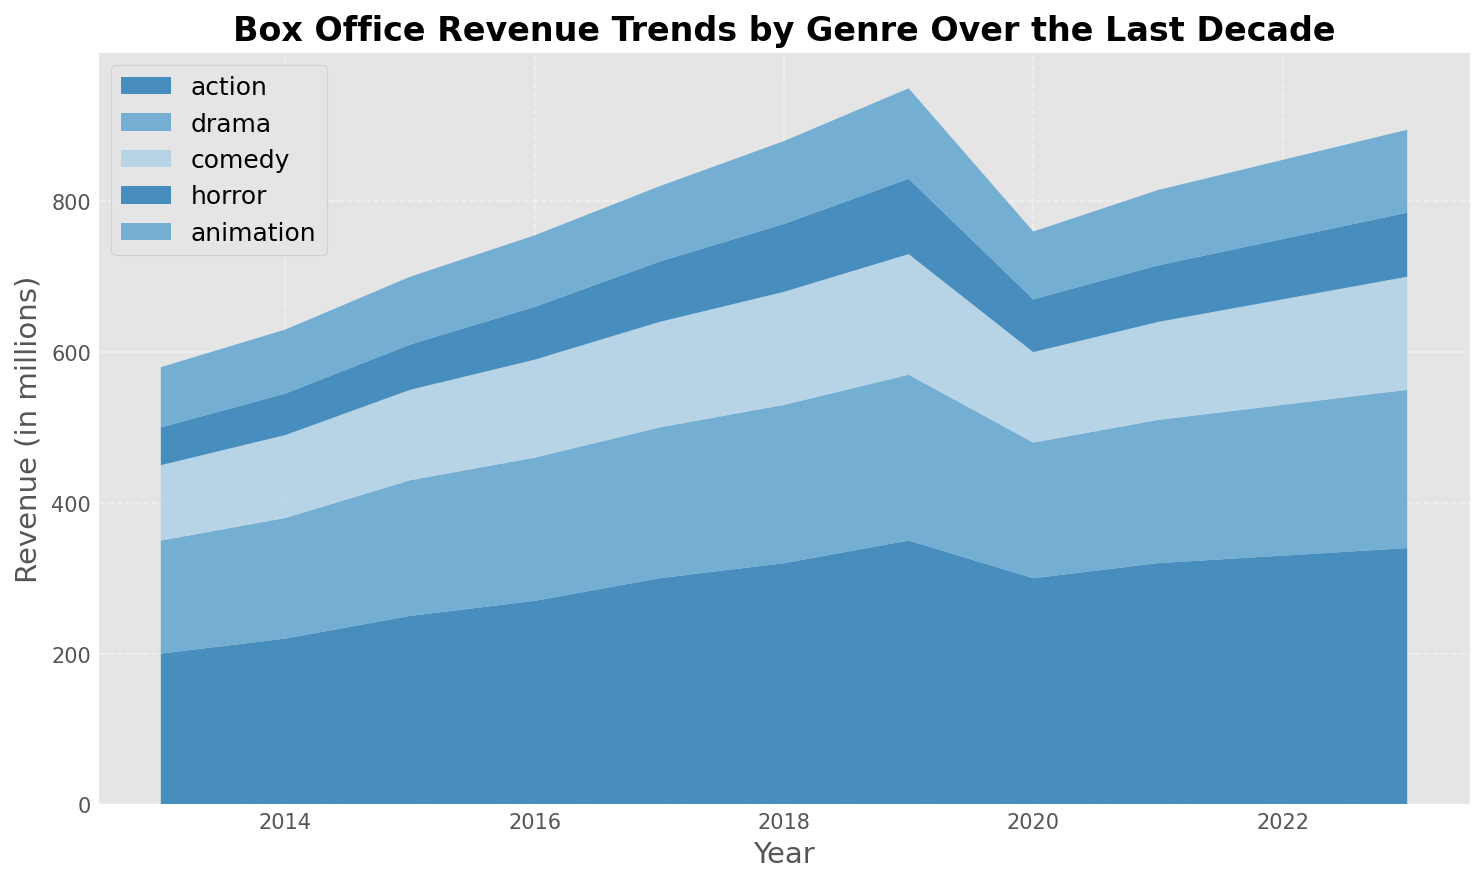What genre showed the greatest increase in box office revenue from 2013 to 2019? To determine the genre with the greatest increase, compare the revenue for each genre in 2013 and 2019. The increase for Action is (350 - 200) = 150, Drama is (220 - 150) = 70, Comedy is (160 - 100) = 60, Horror is (100 - 50) = 50, and Animation is (120 - 80) = 40. Action has the highest increase.
Answer: Action Which genre had the least revenue in 2020, and what was the value? Look at the visual representation for 2020 and identify the shortest stack, which corresponds to the genre with the least revenue. In 2020, Horror has the least revenue.
Answer: Horror, 70 million How did the overall box office revenue trend change for each genre during the pandemic years (2020-2021)? Visually track the area changes for 2020 and 2021 for each genre. Most genres show a decline in 2020 compared to 2019, then a slight recovery in 2021. Action drops to 300 and then to 320 million, Drama to 180 then 190 million, Comedy to 120 then 130 million, Horror to 70 then 75 million, and Animation to 90 then 100 million.
Answer: General dip in 2020, slight recovery in 2021 Across all years, which genre consistently performed the weakest in terms of box office revenue? Identify the genre with the smallest area throughout the chart. Horror genre consistently shows the lowest values compared to other genres in each year.
Answer: Horror What was the combined revenue of Comedy and Animation genres in 2015? Add the revenue for Comedy (120) and Animation (90) for the year 2015. The combined revenue is 120 + 90 = 210 million.
Answer: 210 million Which genre surpassed a revenue of 300 million first, and in which year? Observe the trends for all genres and determine the first instance where any genre crosses 300 million. Action is the first genre to surpass 300 million in 2017.
Answer: Action, 2017 